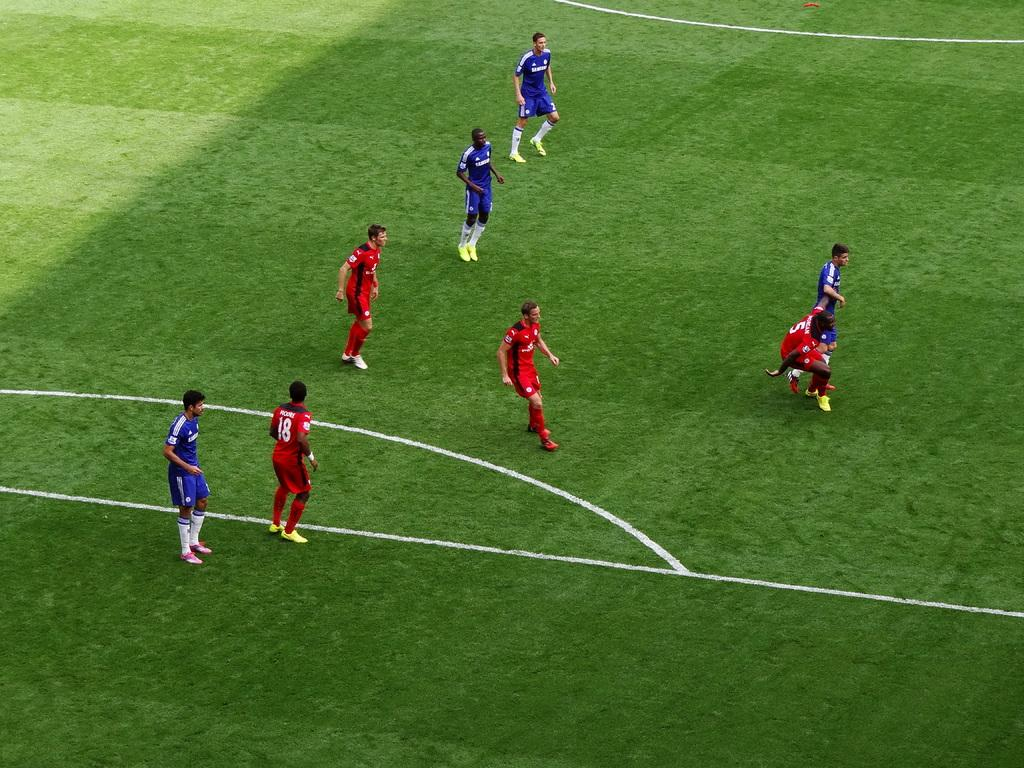<image>
Provide a brief description of the given image. A soccer player with the number 18 on their red jersey is playing with opponents in blue jerseys. 